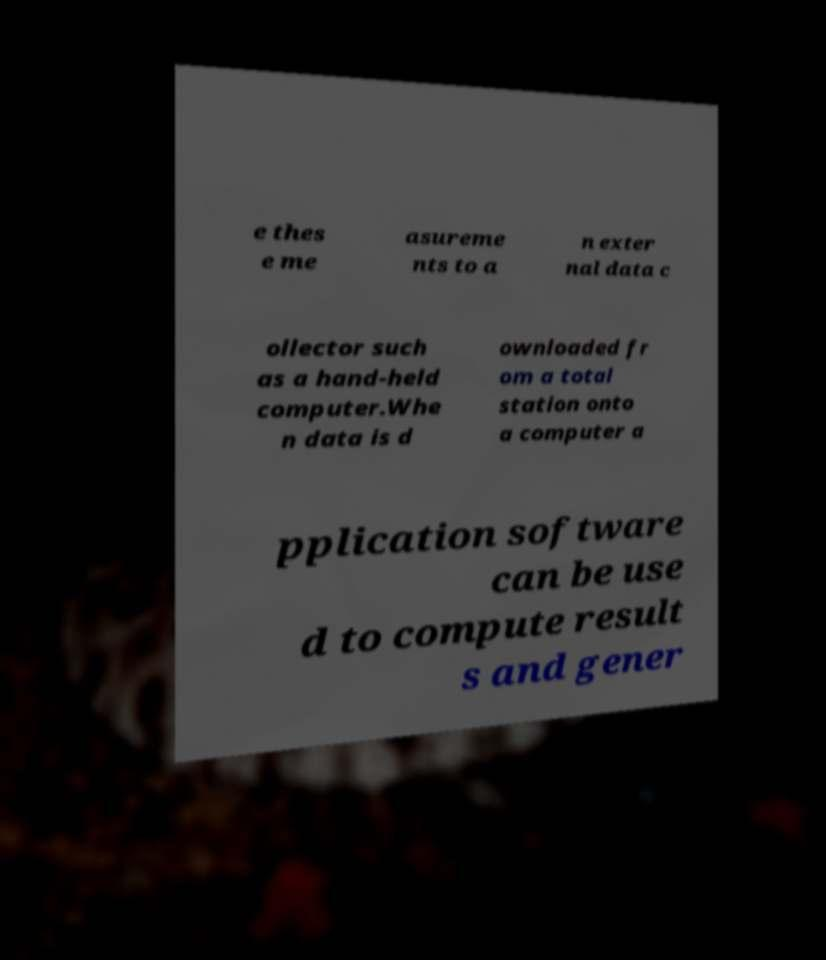Can you accurately transcribe the text from the provided image for me? e thes e me asureme nts to a n exter nal data c ollector such as a hand-held computer.Whe n data is d ownloaded fr om a total station onto a computer a pplication software can be use d to compute result s and gener 